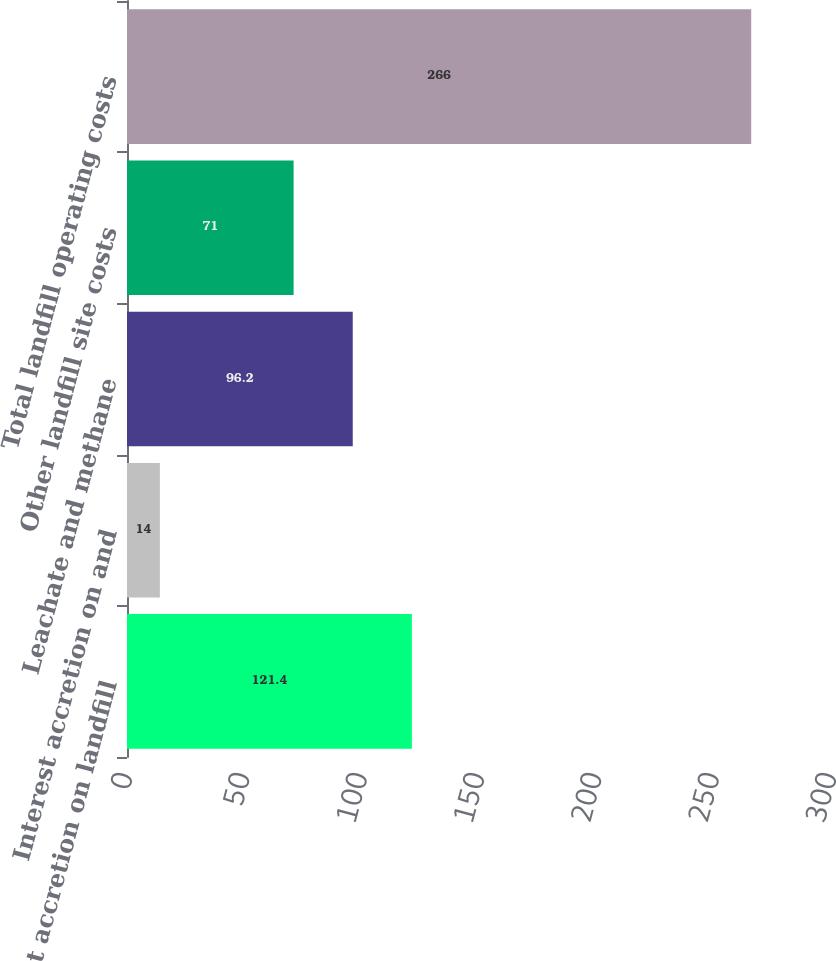Convert chart. <chart><loc_0><loc_0><loc_500><loc_500><bar_chart><fcel>Interest accretion on landfill<fcel>Interest accretion on and<fcel>Leachate and methane<fcel>Other landfill site costs<fcel>Total landfill operating costs<nl><fcel>121.4<fcel>14<fcel>96.2<fcel>71<fcel>266<nl></chart> 